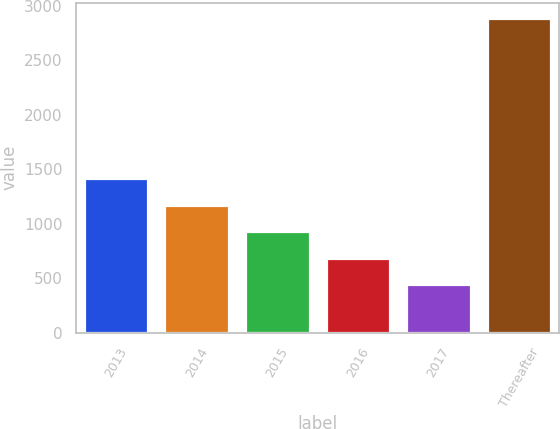<chart> <loc_0><loc_0><loc_500><loc_500><bar_chart><fcel>2013<fcel>2014<fcel>2015<fcel>2016<fcel>2017<fcel>Thereafter<nl><fcel>1418.4<fcel>1174.3<fcel>930.2<fcel>686.1<fcel>442<fcel>2883<nl></chart> 